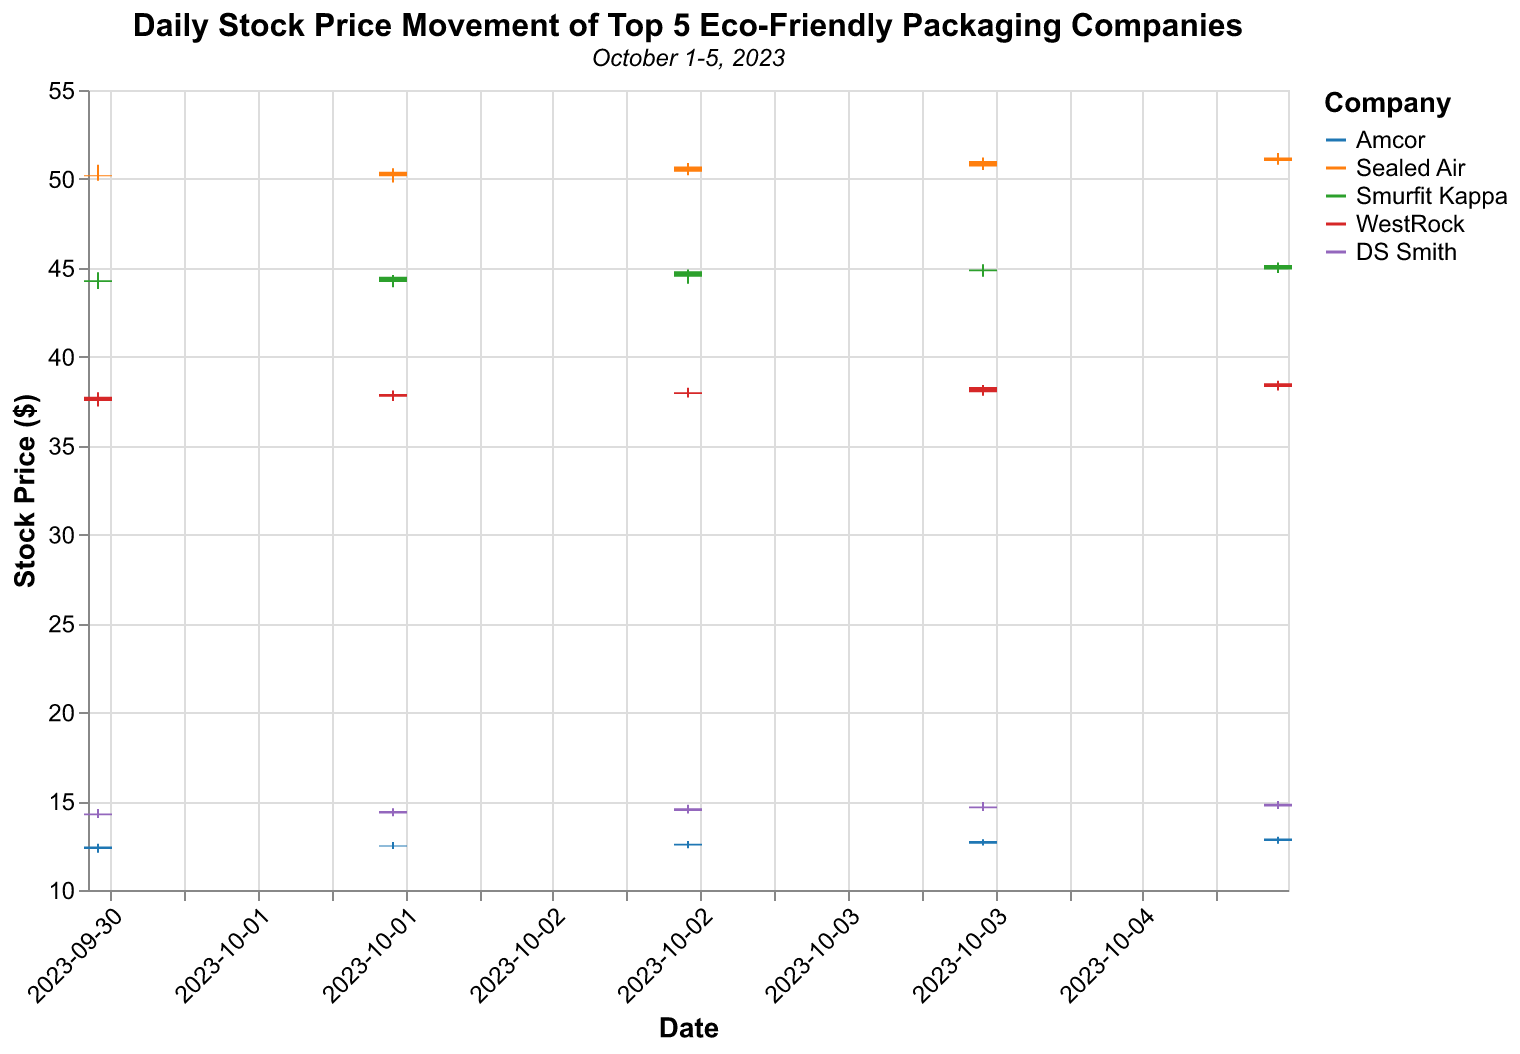What is the title of the figure? The title is usually located at the top of the figure. It summarizes the content to give a quick insight. The title here is displayed prominently at the top.
Answer: Daily Stock Price Movement of Top 5 Eco-Friendly Packaging Companies Which company had the highest closing price on October 1st, 2023? To find the highest closing price, compare the "Close" values of all companies for this date. Sealed Air had the highest closing price of $50.15 on October 1st.
Answer: Sealed Air On which date did DS Smith have its highest closing price within the dataset? Review all "Close" values for DS Smith across the dates provided. The highest closing price for DS Smith, $14.85, occurred on October 5th, 2023.
Answer: October 5th, 2023 Which company showed a consistent increase in its closing price over the five days? By comparing the daily closing prices of each company, we see that only DS Smith has a consistent increase in its closing prices over the five days.
Answer: DS Smith What is the range of high and low prices for Smurfit Kappa on October 3rd, 2023? The "High" and "Low" values for Smurfit Kappa on October 3rd are indicated as $44.90 and $44.10, respectively. The range is calculated as High - Low = $44.90 - $44.10 = $0.80.
Answer: $0.80 How does the opening price of Amcor on October 5th compare to its closing price on October 4th? Compare the opening price of Amcor on October 5th ($12.75) with its closing price on October 4th ($12.75). Both values are the same.
Answer: They are equal Which date had the highest overall stock prices among all companies? Determine the overall stock price for each date by observing the closing prices. October 5th shows the highest closing prices across almost all companies.
Answer: October 5th For WestRock, what is the difference between the highest closing price and the lowest closing price within this dataset? Identify the highest and lowest closing prices for WestRock; the highest is $38.50 (October 5th) and the lowest is $37.75 (October 1st). The difference is $38.50 - $37.75 = $0.75.
Answer: $0.75 Which company had the smallest price fluctuation on October 2nd? Calculate the fluctuation (High - Low) for each company on October 2nd. Amcor has the smallest price fluctuation ($12.70 - $12.30 = $0.40).
Answer: Amcor On October 4th, which company had the largest difference between its opening and closing prices? Calculate the difference between Open and Close prices for each company on October 4th. Sealed Air had the largest difference ($51.00 - $50.70 = $0.30).
Answer: Sealed Air 